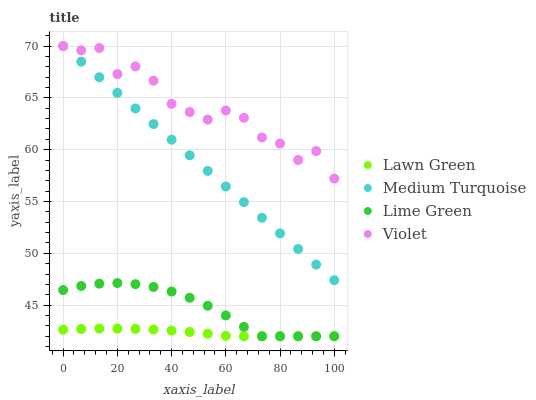Does Lawn Green have the minimum area under the curve?
Answer yes or no. Yes. Does Violet have the maximum area under the curve?
Answer yes or no. Yes. Does Lime Green have the minimum area under the curve?
Answer yes or no. No. Does Lime Green have the maximum area under the curve?
Answer yes or no. No. Is Medium Turquoise the smoothest?
Answer yes or no. Yes. Is Violet the roughest?
Answer yes or no. Yes. Is Lime Green the smoothest?
Answer yes or no. No. Is Lime Green the roughest?
Answer yes or no. No. Does Lawn Green have the lowest value?
Answer yes or no. Yes. Does Medium Turquoise have the lowest value?
Answer yes or no. No. Does Violet have the highest value?
Answer yes or no. Yes. Does Lime Green have the highest value?
Answer yes or no. No. Is Lime Green less than Medium Turquoise?
Answer yes or no. Yes. Is Violet greater than Lawn Green?
Answer yes or no. Yes. Does Medium Turquoise intersect Violet?
Answer yes or no. Yes. Is Medium Turquoise less than Violet?
Answer yes or no. No. Is Medium Turquoise greater than Violet?
Answer yes or no. No. Does Lime Green intersect Medium Turquoise?
Answer yes or no. No. 